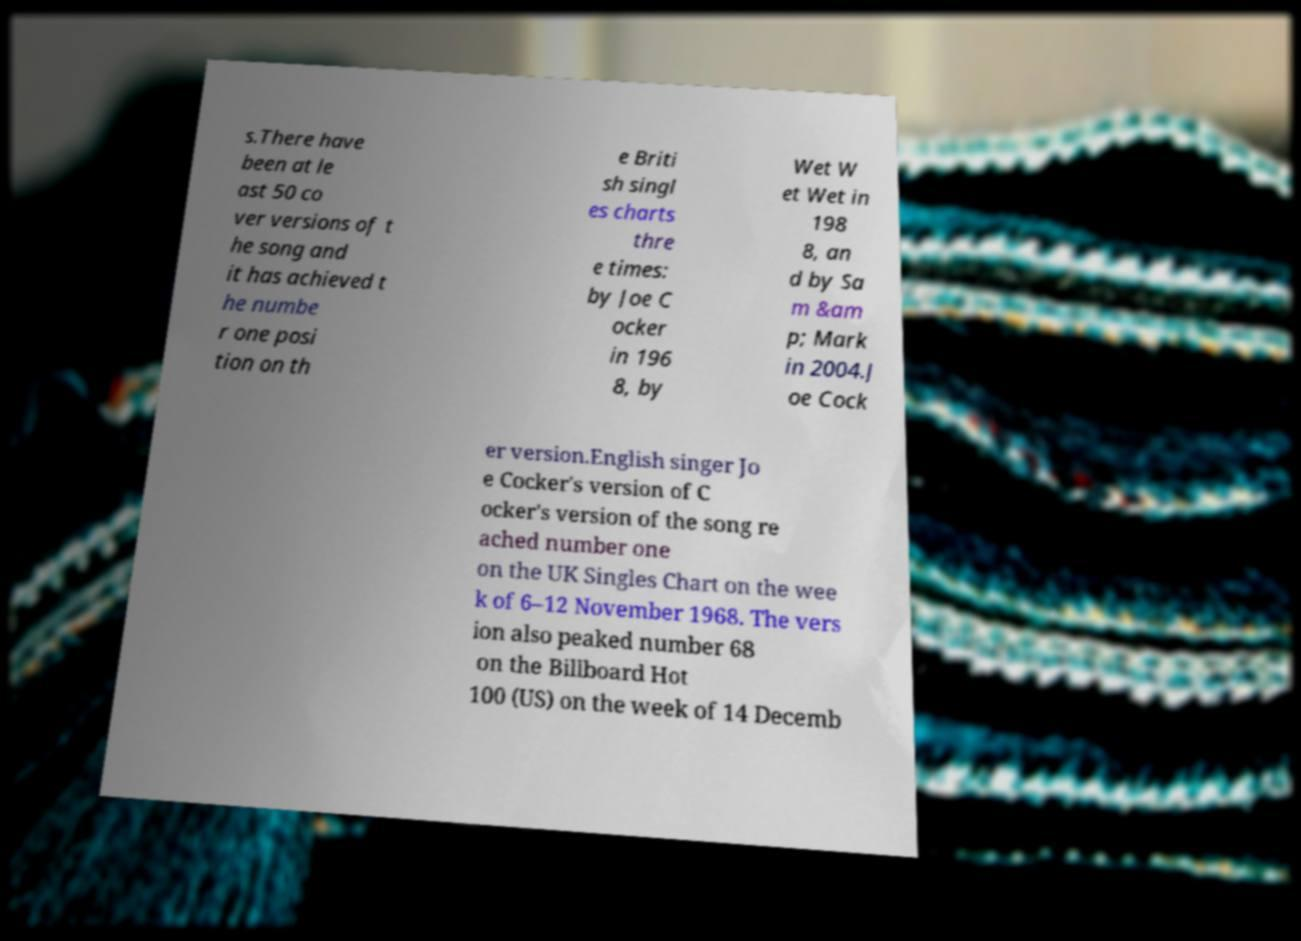Could you assist in decoding the text presented in this image and type it out clearly? s.There have been at le ast 50 co ver versions of t he song and it has achieved t he numbe r one posi tion on th e Briti sh singl es charts thre e times: by Joe C ocker in 196 8, by Wet W et Wet in 198 8, an d by Sa m &am p; Mark in 2004.J oe Cock er version.English singer Jo e Cocker's version of C ocker's version of the song re ached number one on the UK Singles Chart on the wee k of 6–12 November 1968. The vers ion also peaked number 68 on the Billboard Hot 100 (US) on the week of 14 Decemb 